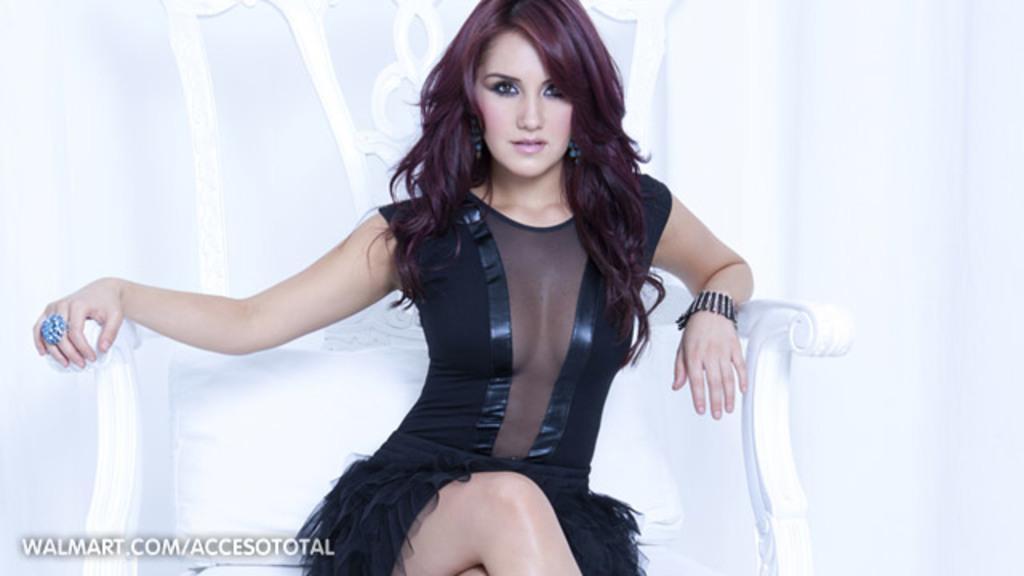Could you give a brief overview of what you see in this image? In this image there is a girl in black dress sitting on the white chair, also wearing bracelet and ring. 